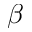Convert formula to latex. <formula><loc_0><loc_0><loc_500><loc_500>\beta</formula> 